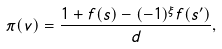<formula> <loc_0><loc_0><loc_500><loc_500>\pi ( v ) = \frac { 1 + f ( s ) - ( - 1 ) ^ { \xi } f ( s ^ { \prime } ) } { d } ,</formula> 